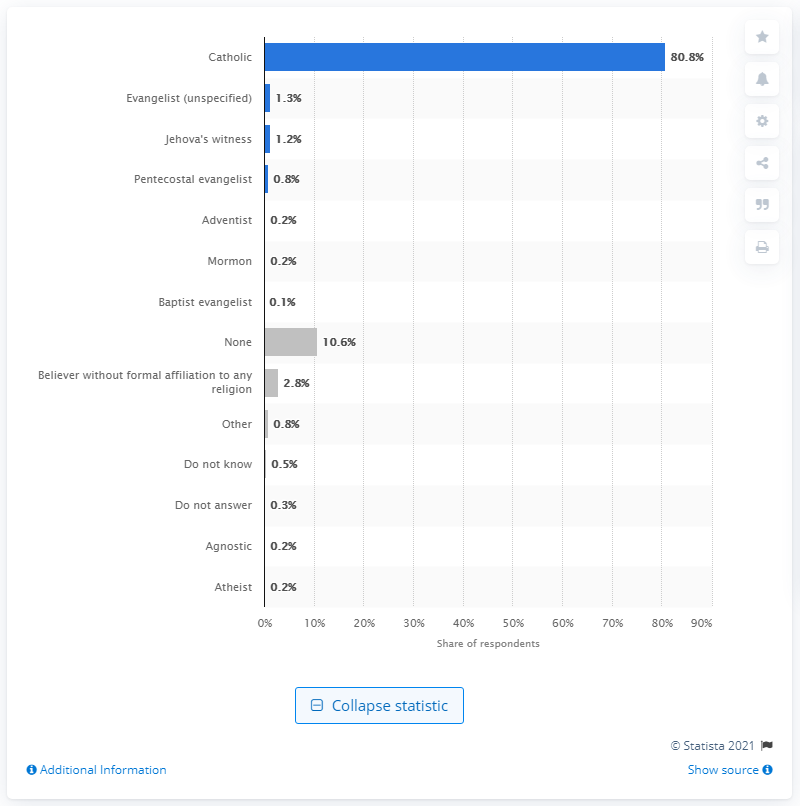Give some essential details in this illustration. According to a survey, 80.8% of Mexicans claimed to be Catholic in faith. A survey was conducted among Mexicans, and the results showed that 1.3% of them identified as Evangelicals. 